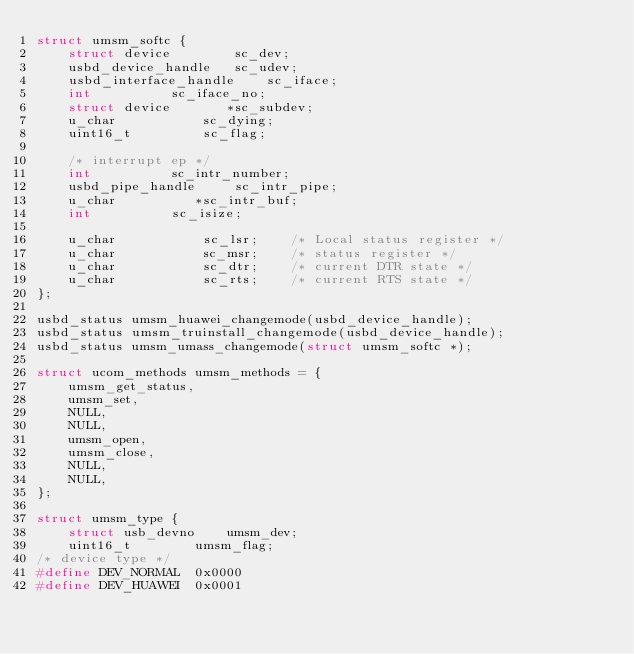Convert code to text. <code><loc_0><loc_0><loc_500><loc_500><_C_>struct umsm_softc {
	struct device		 sc_dev;
	usbd_device_handle	 sc_udev;
	usbd_interface_handle	 sc_iface;
	int			 sc_iface_no;
	struct device		*sc_subdev;
	u_char			 sc_dying;
	uint16_t		 sc_flag;

	/* interrupt ep */
	int			 sc_intr_number;
	usbd_pipe_handle	 sc_intr_pipe;
	u_char			*sc_intr_buf;
	int			 sc_isize;

	u_char			 sc_lsr;	/* Local status register */
	u_char			 sc_msr;	/* status register */
	u_char			 sc_dtr;	/* current DTR state */
	u_char			 sc_rts;	/* current RTS state */
};

usbd_status umsm_huawei_changemode(usbd_device_handle);
usbd_status umsm_truinstall_changemode(usbd_device_handle);
usbd_status umsm_umass_changemode(struct umsm_softc *);

struct ucom_methods umsm_methods = {
	umsm_get_status,
	umsm_set,
	NULL,
	NULL,
	umsm_open,
	umsm_close,
	NULL,
	NULL,
};

struct umsm_type {
	struct usb_devno	umsm_dev;
	uint16_t		umsm_flag;
/* device type */
#define	DEV_NORMAL	0x0000
#define	DEV_HUAWEI	0x0001</code> 